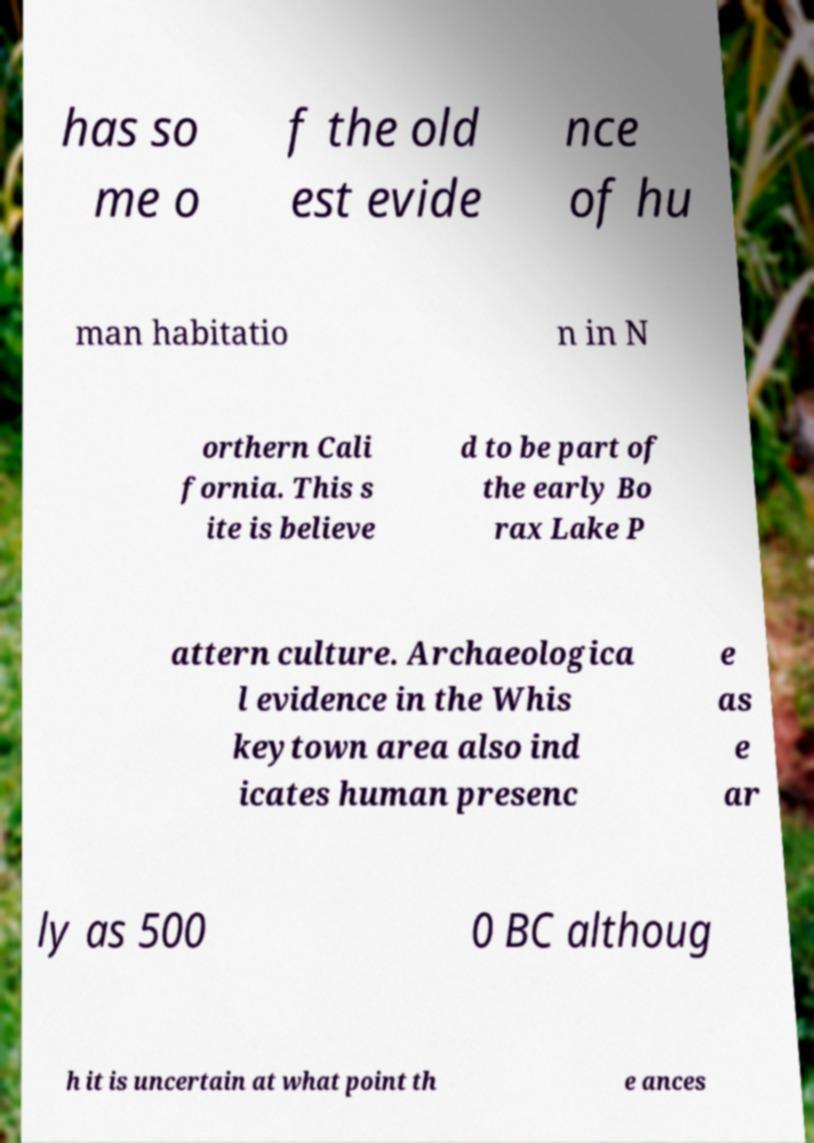I need the written content from this picture converted into text. Can you do that? has so me o f the old est evide nce of hu man habitatio n in N orthern Cali fornia. This s ite is believe d to be part of the early Bo rax Lake P attern culture. Archaeologica l evidence in the Whis keytown area also ind icates human presenc e as e ar ly as 500 0 BC althoug h it is uncertain at what point th e ances 